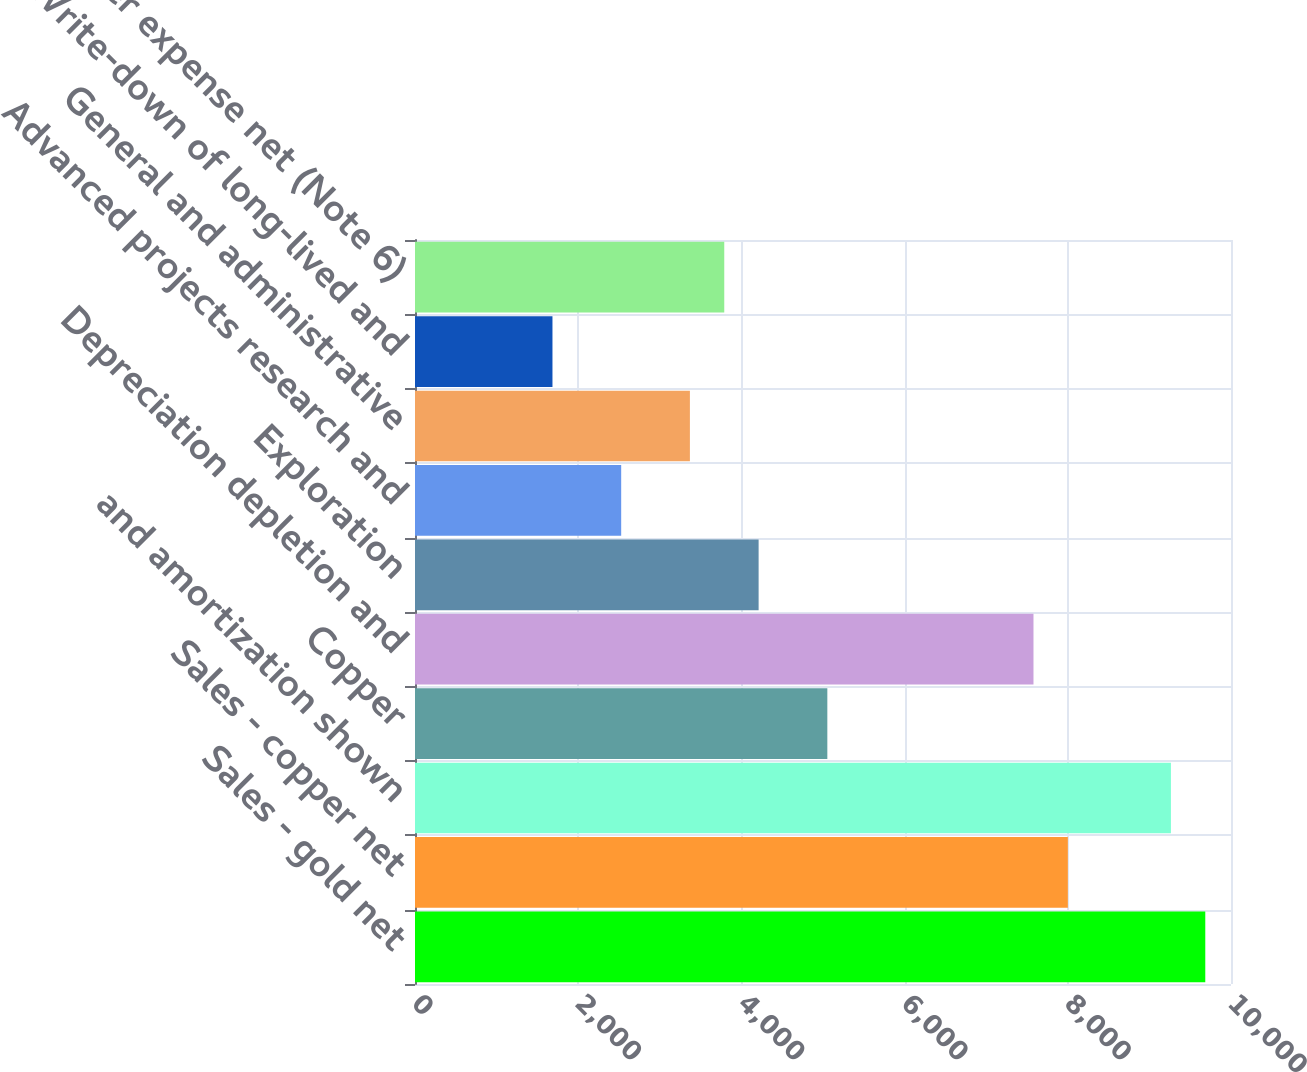Convert chart. <chart><loc_0><loc_0><loc_500><loc_500><bar_chart><fcel>Sales - gold net<fcel>Sales - copper net<fcel>and amortization shown<fcel>Copper<fcel>Depreciation depletion and<fcel>Exploration<fcel>Advanced projects research and<fcel>General and administrative<fcel>Write-down of long-lived and<fcel>Other expense net (Note 6)<nl><fcel>9684.78<fcel>8000.54<fcel>9263.72<fcel>5053.12<fcel>7579.48<fcel>4211<fcel>2526.76<fcel>3368.88<fcel>1684.64<fcel>3789.94<nl></chart> 